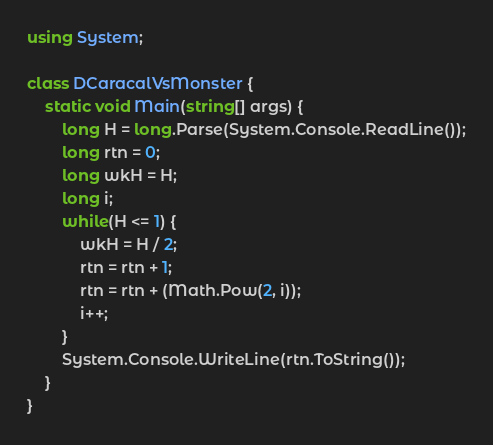Convert code to text. <code><loc_0><loc_0><loc_500><loc_500><_C#_>using System;

class DCaracalVsMonster {
    static void Main(string[] args) {
        long H = long.Parse(System.Console.ReadLine());
        long rtn = 0;
        long wkH = H;
        long i;
        while(H <= 1) {
            wkH = H / 2;
            rtn = rtn + 1;
            rtn = rtn + (Math.Pow(2, i));
            i++;
        }
        System.Console.WriteLine(rtn.ToString());
    }
}
</code> 